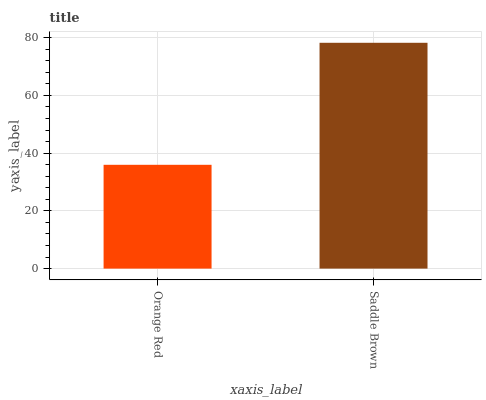Is Orange Red the minimum?
Answer yes or no. Yes. Is Saddle Brown the maximum?
Answer yes or no. Yes. Is Saddle Brown the minimum?
Answer yes or no. No. Is Saddle Brown greater than Orange Red?
Answer yes or no. Yes. Is Orange Red less than Saddle Brown?
Answer yes or no. Yes. Is Orange Red greater than Saddle Brown?
Answer yes or no. No. Is Saddle Brown less than Orange Red?
Answer yes or no. No. Is Saddle Brown the high median?
Answer yes or no. Yes. Is Orange Red the low median?
Answer yes or no. Yes. Is Orange Red the high median?
Answer yes or no. No. Is Saddle Brown the low median?
Answer yes or no. No. 